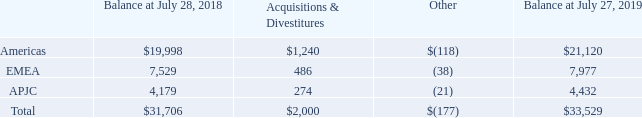5. Goodwill and Purchased Intangible Assets
(a) Goodwill
The following tables present the goodwill allocated to our reportable segments as of July 27, 2019 and July 28, 2018, as well as the changes to goodwill during fiscal 2019 and 2018 (in millions):
“Other” in the tables above primarily consists of foreign currency translation as well as immaterial purchase accounting adjustments.
Which years does the table provide information for the goodwill associated to the company's reportable segments? 2019, 2018. What does Other primarily consist of? Foreign currency translation as well as immaterial purchase accounting adjustments. What was the Total balance at July 28, 2018?
Answer scale should be: million. 31,706. What was the change in balance from Americas between 2018 and 2019?
Answer scale should be: million. 21,120-19,998
Answer: 1122. What was the region with the highest  Acquisitions & Divestitures? Compare and find the largest number for Acquisitions & Divestitures for Americas, EMEA and APJC
Answer: americas. What was the percentage change in the total balance between 2018 and 2019?
Answer scale should be: percent. (33,529-31,706)/31,706
Answer: 5.75. 